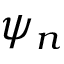Convert formula to latex. <formula><loc_0><loc_0><loc_500><loc_500>\psi _ { n }</formula> 